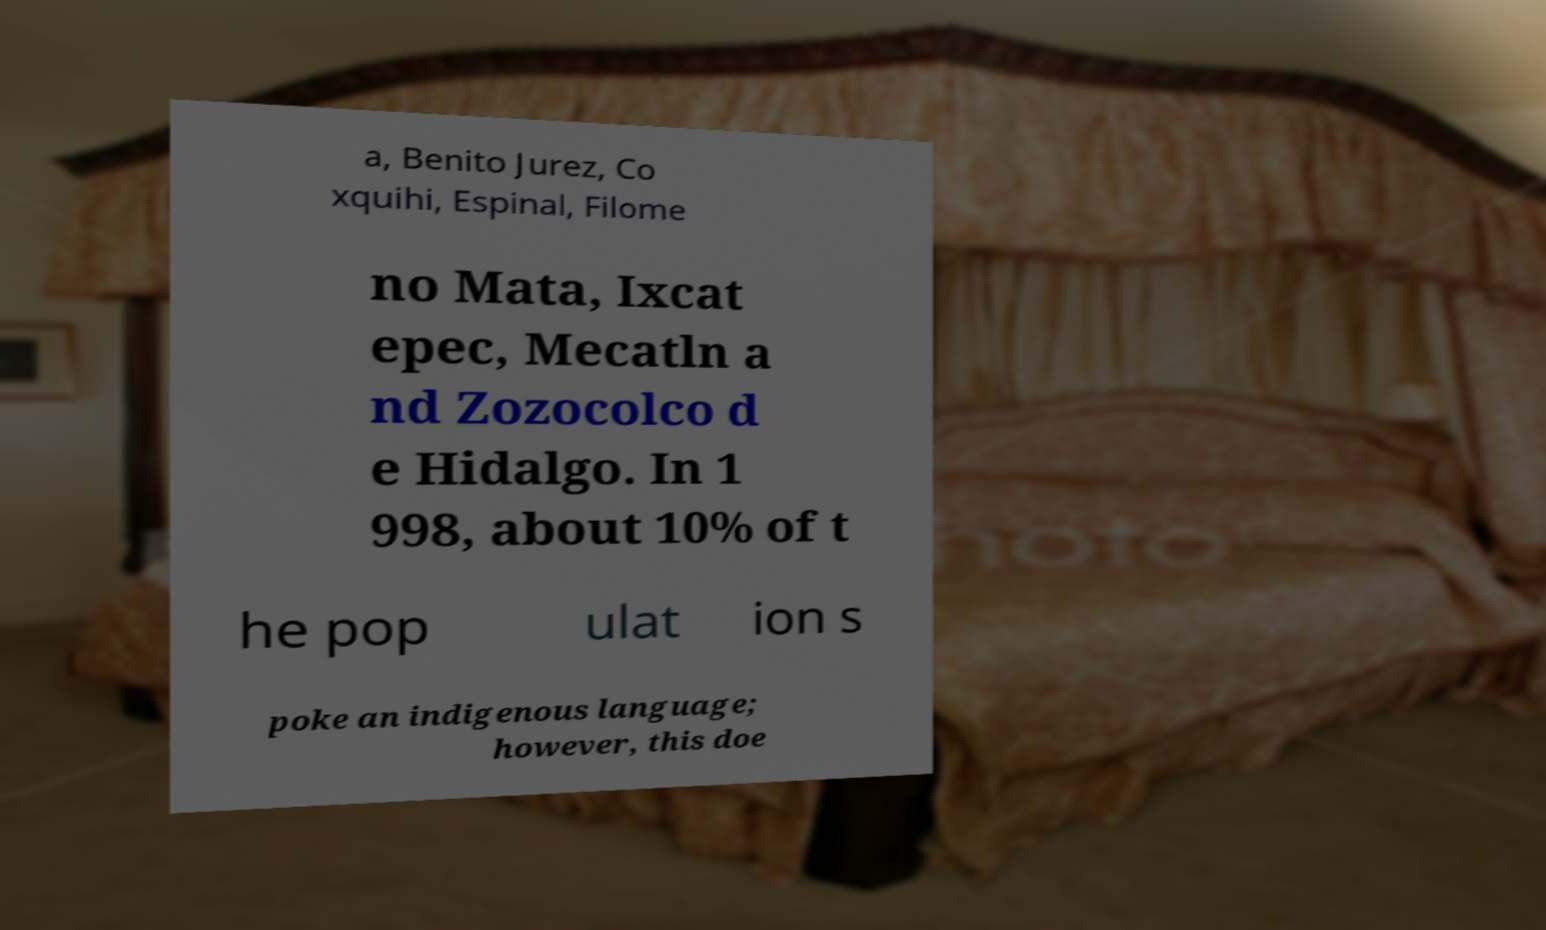There's text embedded in this image that I need extracted. Can you transcribe it verbatim? a, Benito Jurez, Co xquihi, Espinal, Filome no Mata, Ixcat epec, Mecatln a nd Zozocolco d e Hidalgo. In 1 998, about 10% of t he pop ulat ion s poke an indigenous language; however, this doe 